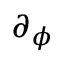<formula> <loc_0><loc_0><loc_500><loc_500>\partial _ { \phi }</formula> 